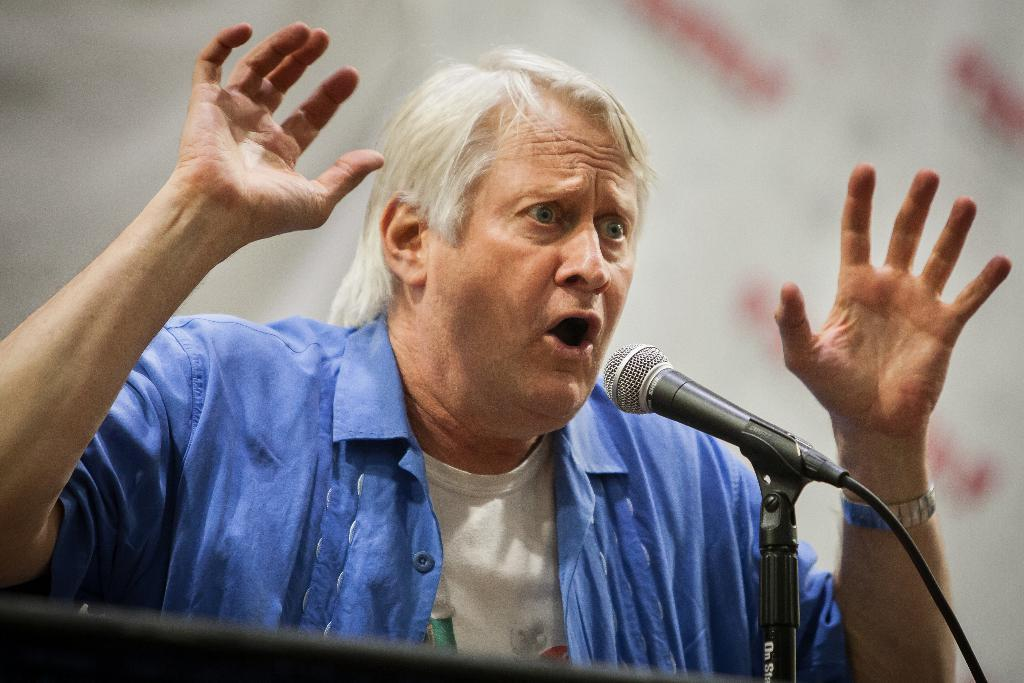What is the main subject of the image? The main subject of the image is a man. What is the man doing in the image? The man is speaking in the image. What object is present in front of the man? There is a microphone in front of the man. What type of condition does the man have in the image? There is no information about the man's condition in the image. What point is the man trying to make in the image? We cannot determine the man's point from the image alone, as we do not have access to the content of his speech. 